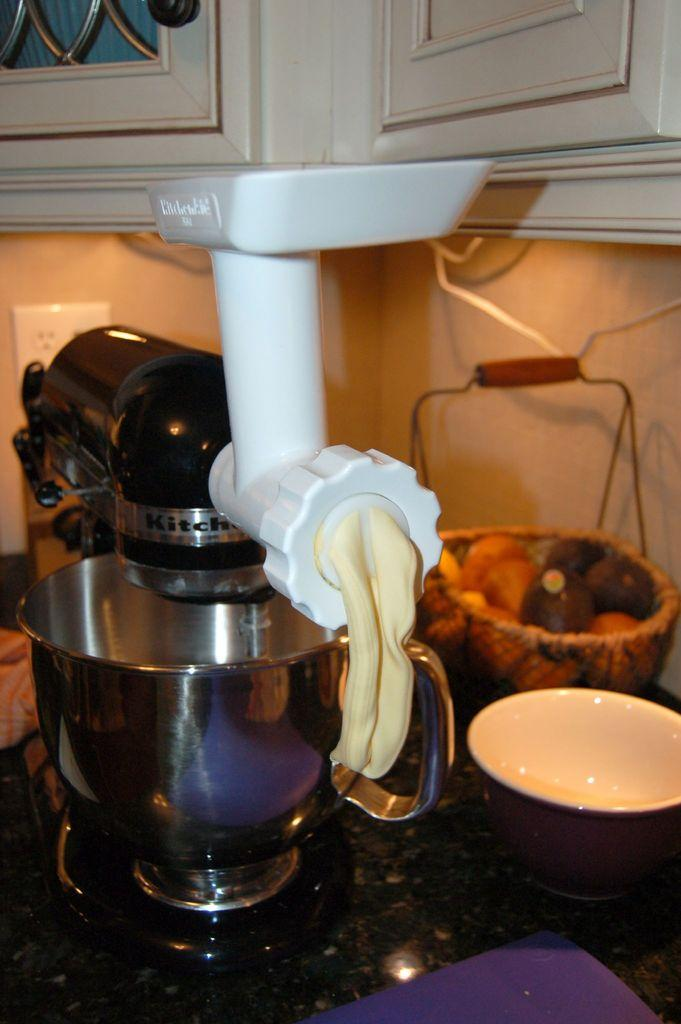<image>
Share a concise interpretation of the image provided. Dough comes out the end of an attachment affixed to a mixer with the word kitchen on it. 